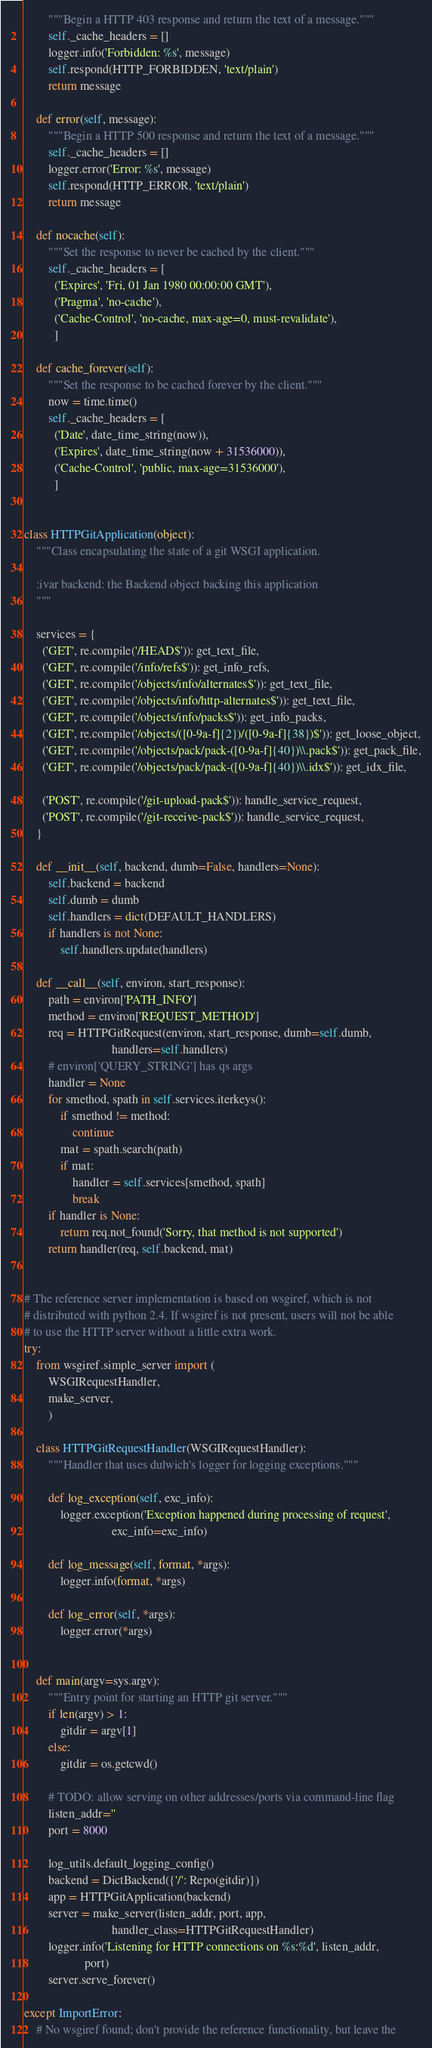Convert code to text. <code><loc_0><loc_0><loc_500><loc_500><_Python_>        """Begin a HTTP 403 response and return the text of a message."""
        self._cache_headers = []
        logger.info('Forbidden: %s', message)
        self.respond(HTTP_FORBIDDEN, 'text/plain')
        return message

    def error(self, message):
        """Begin a HTTP 500 response and return the text of a message."""
        self._cache_headers = []
        logger.error('Error: %s', message)
        self.respond(HTTP_ERROR, 'text/plain')
        return message

    def nocache(self):
        """Set the response to never be cached by the client."""
        self._cache_headers = [
          ('Expires', 'Fri, 01 Jan 1980 00:00:00 GMT'),
          ('Pragma', 'no-cache'),
          ('Cache-Control', 'no-cache, max-age=0, must-revalidate'),
          ]

    def cache_forever(self):
        """Set the response to be cached forever by the client."""
        now = time.time()
        self._cache_headers = [
          ('Date', date_time_string(now)),
          ('Expires', date_time_string(now + 31536000)),
          ('Cache-Control', 'public, max-age=31536000'),
          ]


class HTTPGitApplication(object):
    """Class encapsulating the state of a git WSGI application.

    :ivar backend: the Backend object backing this application
    """

    services = {
      ('GET', re.compile('/HEAD$')): get_text_file,
      ('GET', re.compile('/info/refs$')): get_info_refs,
      ('GET', re.compile('/objects/info/alternates$')): get_text_file,
      ('GET', re.compile('/objects/info/http-alternates$')): get_text_file,
      ('GET', re.compile('/objects/info/packs$')): get_info_packs,
      ('GET', re.compile('/objects/([0-9a-f]{2})/([0-9a-f]{38})$')): get_loose_object,
      ('GET', re.compile('/objects/pack/pack-([0-9a-f]{40})\\.pack$')): get_pack_file,
      ('GET', re.compile('/objects/pack/pack-([0-9a-f]{40})\\.idx$')): get_idx_file,

      ('POST', re.compile('/git-upload-pack$')): handle_service_request,
      ('POST', re.compile('/git-receive-pack$')): handle_service_request,
    }

    def __init__(self, backend, dumb=False, handlers=None):
        self.backend = backend
        self.dumb = dumb
        self.handlers = dict(DEFAULT_HANDLERS)
        if handlers is not None:
            self.handlers.update(handlers)

    def __call__(self, environ, start_response):
        path = environ['PATH_INFO']
        method = environ['REQUEST_METHOD']
        req = HTTPGitRequest(environ, start_response, dumb=self.dumb,
                             handlers=self.handlers)
        # environ['QUERY_STRING'] has qs args
        handler = None
        for smethod, spath in self.services.iterkeys():
            if smethod != method:
                continue
            mat = spath.search(path)
            if mat:
                handler = self.services[smethod, spath]
                break
        if handler is None:
            return req.not_found('Sorry, that method is not supported')
        return handler(req, self.backend, mat)


# The reference server implementation is based on wsgiref, which is not
# distributed with python 2.4. If wsgiref is not present, users will not be able
# to use the HTTP server without a little extra work.
try:
    from wsgiref.simple_server import (
        WSGIRequestHandler,
        make_server,
        )

    class HTTPGitRequestHandler(WSGIRequestHandler):
        """Handler that uses dulwich's logger for logging exceptions."""

        def log_exception(self, exc_info):
            logger.exception('Exception happened during processing of request',
                             exc_info=exc_info)

        def log_message(self, format, *args):
            logger.info(format, *args)

        def log_error(self, *args):
            logger.error(*args)


    def main(argv=sys.argv):
        """Entry point for starting an HTTP git server."""
        if len(argv) > 1:
            gitdir = argv[1]
        else:
            gitdir = os.getcwd()

        # TODO: allow serving on other addresses/ports via command-line flag
        listen_addr=''
        port = 8000

        log_utils.default_logging_config()
        backend = DictBackend({'/': Repo(gitdir)})
        app = HTTPGitApplication(backend)
        server = make_server(listen_addr, port, app,
                             handler_class=HTTPGitRequestHandler)
        logger.info('Listening for HTTP connections on %s:%d', listen_addr,
                    port)
        server.serve_forever()

except ImportError:
    # No wsgiref found; don't provide the reference functionality, but leave the</code> 